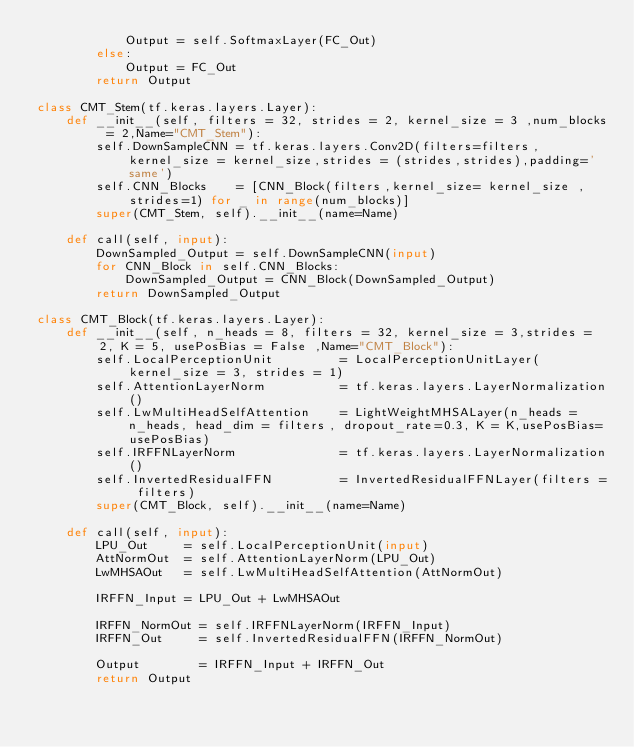Convert code to text. <code><loc_0><loc_0><loc_500><loc_500><_Python_>            Output = self.SoftmaxLayer(FC_Out)
        else:
            Output = FC_Out
        return Output
        
class CMT_Stem(tf.keras.layers.Layer):
    def __init__(self, filters = 32, strides = 2, kernel_size = 3 ,num_blocks = 2,Name="CMT_Stem"):    
        self.DownSampleCNN = tf.keras.layers.Conv2D(filters=filters,kernel_size = kernel_size,strides = (strides,strides),padding='same')
        self.CNN_Blocks    = [CNN_Block(filters,kernel_size= kernel_size ,strides=1) for _ in range(num_blocks)]  
        super(CMT_Stem, self).__init__(name=Name)        

    def call(self, input):
        DownSampled_Output = self.DownSampleCNN(input)
        for CNN_Block in self.CNN_Blocks:
            DownSampled_Output = CNN_Block(DownSampled_Output)        
        return DownSampled_Output
    
class CMT_Block(tf.keras.layers.Layer):
    def __init__(self, n_heads = 8, filters = 32, kernel_size = 3,strides = 2, K = 5, usePosBias = False ,Name="CMT_Block"):
        self.LocalPerceptionUnit         = LocalPerceptionUnitLayer(kernel_size = 3, strides = 1)
        self.AttentionLayerNorm          = tf.keras.layers.LayerNormalization()
        self.LwMultiHeadSelfAttention    = LightWeightMHSALayer(n_heads = n_heads, head_dim = filters, dropout_rate=0.3, K = K,usePosBias=usePosBias)
        self.IRFFNLayerNorm              = tf.keras.layers.LayerNormalization()
        self.InvertedResidualFFN         = InvertedResidualFFNLayer(filters = filters)
        super(CMT_Block, self).__init__(name=Name)        

    def call(self, input):
        LPU_Out     = self.LocalPerceptionUnit(input)
        AttNormOut  = self.AttentionLayerNorm(LPU_Out)
        LwMHSAOut   = self.LwMultiHeadSelfAttention(AttNormOut)

        IRFFN_Input = LPU_Out + LwMHSAOut

        IRFFN_NormOut = self.IRFFNLayerNorm(IRFFN_Input)
        IRFFN_Out     = self.InvertedResidualFFN(IRFFN_NormOut)

        Output        = IRFFN_Input + IRFFN_Out
        return Output</code> 